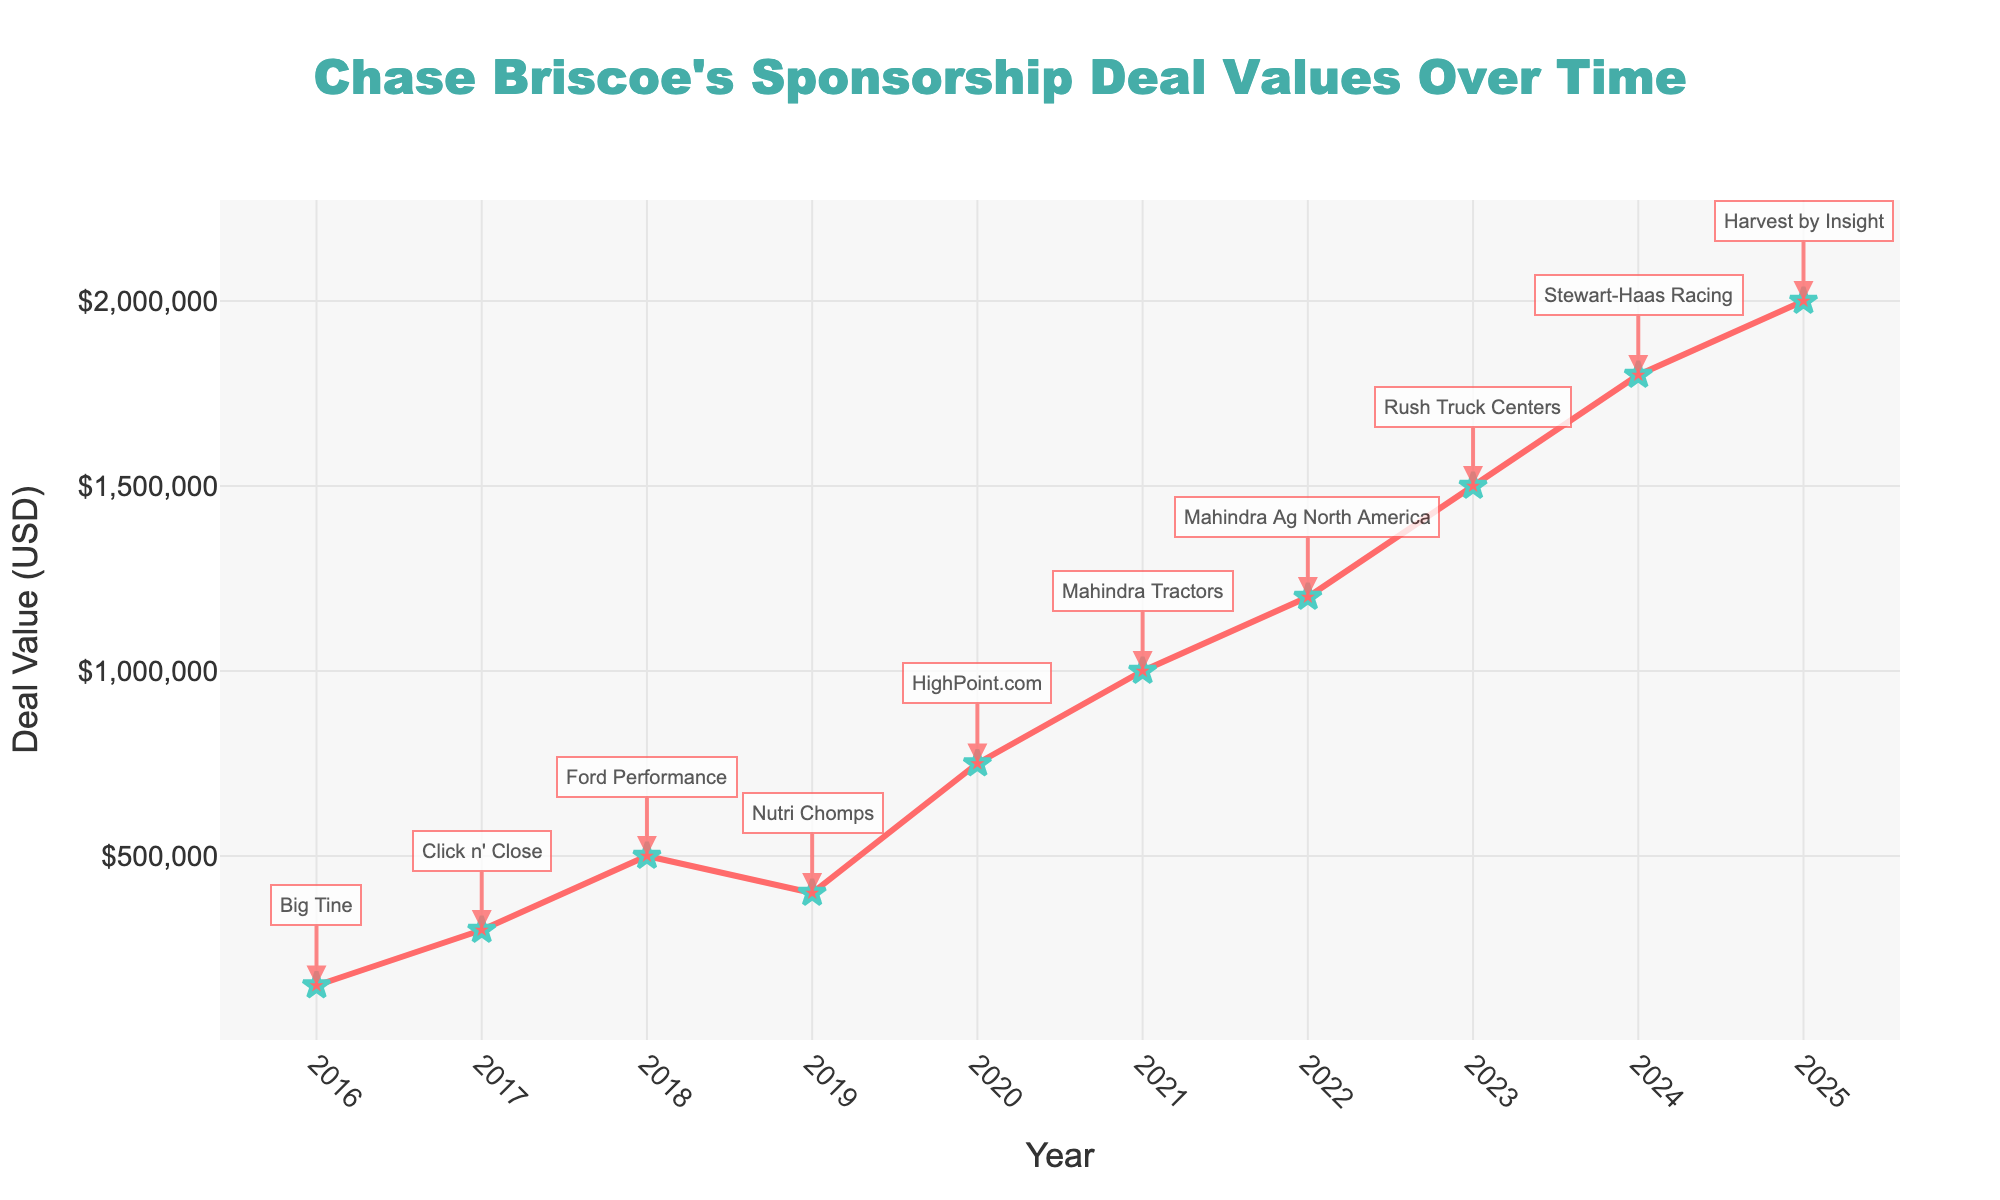What's the trend in sponsorship deal values for Chase Briscoe's car from 2016 to 2025? Observe the general direction of the line chart from 2016 to 2025. The values start at $150,000 in 2016 and rise steadily each year, reaching $2,000,000 in 2025.
Answer: Increasing Which year saw the highest increase in deal value compared to the previous year? Look at the differences in deal values from each year to the next. The largest increase is from 2019 ($400,000) to 2020 ($750,000), which is an increase of $350,000.
Answer: 2020 What is the total sum of Chase Briscoe's sponsorship deal values from 2016 to 2025? Sum all the deal values provided in the data: $150,000 + $300,000 + $500,000 + $400,000 + $750,000 + $1,000,000 + $1,200,000 + $1,500,000 + $1,800,000 + $2,000,000 = $9,600,000.
Answer: $9,600,000 What is the average deal value over the 10-year period? Calculate the average by summing all deal values and dividing by the number of years: $9,600,000 / 10 = $960,000.
Answer: $960,000 Which sponsor contributed the highest deal value and in what year? Check the deal values and corresponding sponsors. The highest deal value is $2,000,000 by "Harvest by Insight" in 2025.
Answer: Harvest by Insight, 2025 Between which years was the deal value steady without any increase or decrease? Check if any consecutive years have the same deal value. There are no consecutive years with the same deal value; each year shows an increase.
Answer: None Compare the deal value for 2018 and 2023. Which year had a higher value and by how much? The deal value in 2018 is $500,000, and in 2023 it is $1,500,000. The difference is $1,500,000 - $500,000 = $1,000,000.
Answer: 2023 by $1,000,000 How many years did it take for the sponsorship deal value to exceed $1,000,000? Observe the values and find the first year after 2016 that exceeds $1,000,000. The deal value is exceeded in 2021. Starting from 2016, it takes 5 years to reach 2021.
Answer: 5 years Which sponsor appears in the two consecutive years with the highest combined deal value? Identify sponsors in consecutive years and sum their values. "Mahindra" in 2021 ($1,000,000) and "Mahindra Ag North America" in 2022 ($1,200,000) have a combined total of $2,200,000.
Answer: Mahindra What is the median sponsorship deal value from 2016 to 2025? Organize the deal values in ascending order: $150,000, $300,000, $400,000, $500,000, $750,000, $1,000,000, $1,200,000, $1,500,000, $1,800,000, $2,000,000. The median is the average of the 5th and 6th values: ($750,000 + $1,000,000) / 2 = $875,000.
Answer: $875,000 